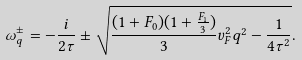<formula> <loc_0><loc_0><loc_500><loc_500>\omega ^ { \pm } _ { q } = - \frac { i } { 2 \tau } \pm \sqrt { \frac { ( 1 + F _ { 0 } ) ( 1 + \frac { F _ { 1 } } { 3 } ) } { 3 } v _ { F } ^ { 2 } q ^ { 2 } - \frac { 1 } { 4 \tau ^ { 2 } } } .</formula> 